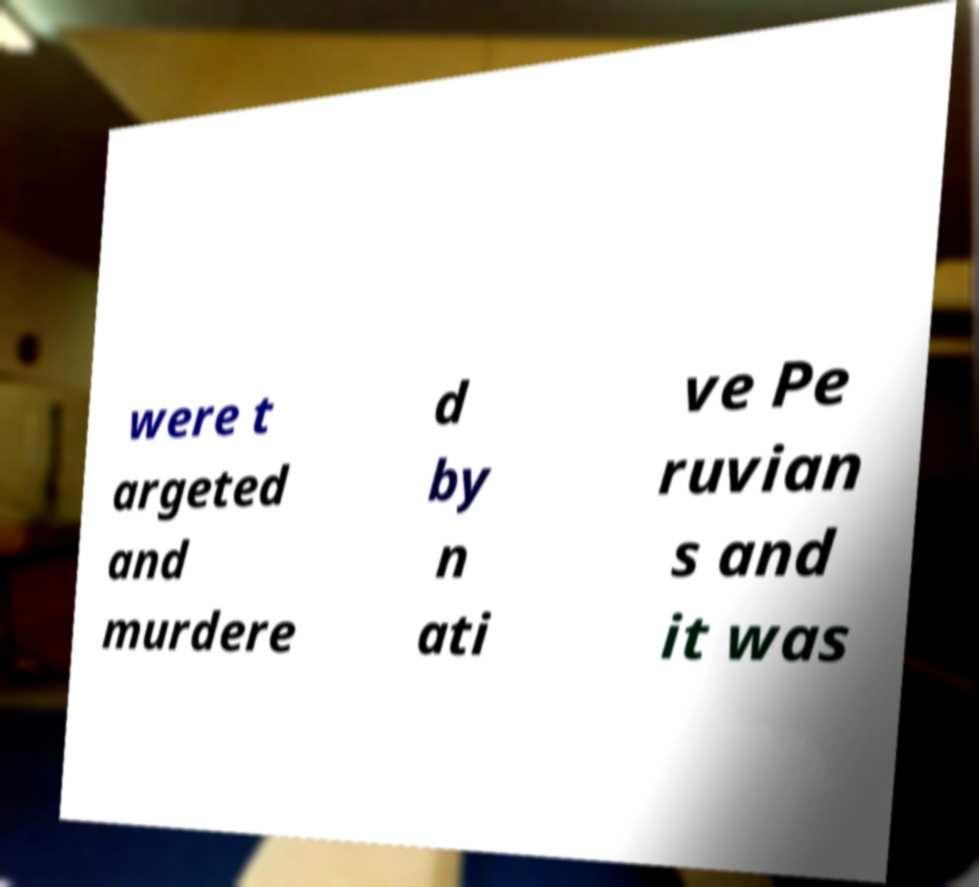For documentation purposes, I need the text within this image transcribed. Could you provide that? were t argeted and murdere d by n ati ve Pe ruvian s and it was 